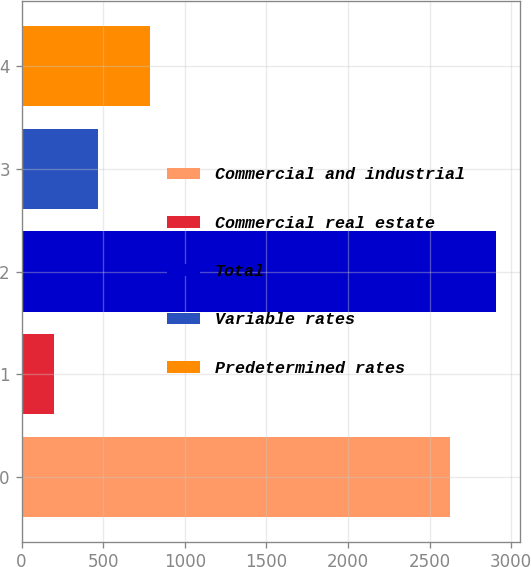Convert chart. <chart><loc_0><loc_0><loc_500><loc_500><bar_chart><fcel>Commercial and industrial<fcel>Commercial real estate<fcel>Total<fcel>Variable rates<fcel>Predetermined rates<nl><fcel>2627.2<fcel>197.7<fcel>2908.1<fcel>468.74<fcel>790<nl></chart> 